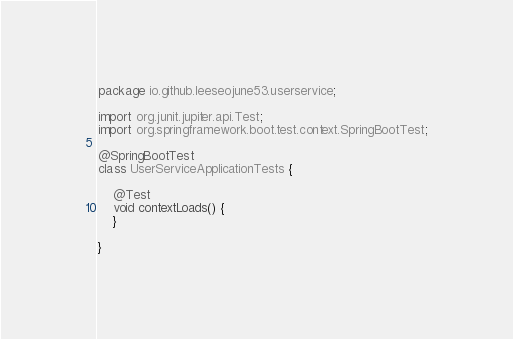Convert code to text. <code><loc_0><loc_0><loc_500><loc_500><_Java_>package io.github.leeseojune53.userservice;

import org.junit.jupiter.api.Test;
import org.springframework.boot.test.context.SpringBootTest;

@SpringBootTest
class UserServiceApplicationTests {

    @Test
    void contextLoads() {
    }

}
</code> 